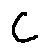<formula> <loc_0><loc_0><loc_500><loc_500>C</formula> 